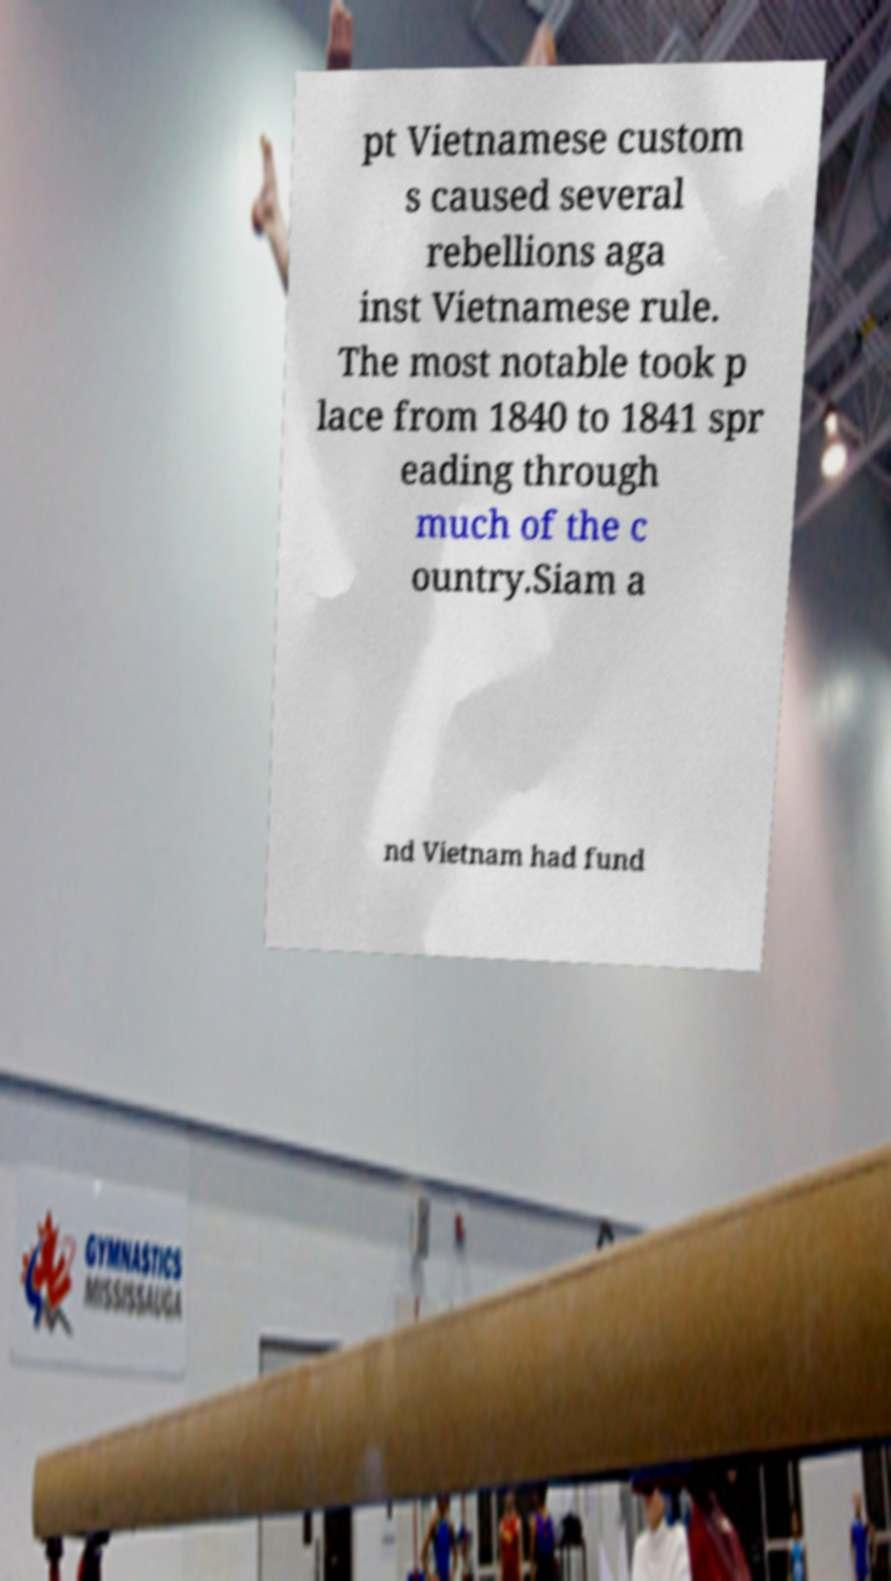Can you accurately transcribe the text from the provided image for me? pt Vietnamese custom s caused several rebellions aga inst Vietnamese rule. The most notable took p lace from 1840 to 1841 spr eading through much of the c ountry.Siam a nd Vietnam had fund 